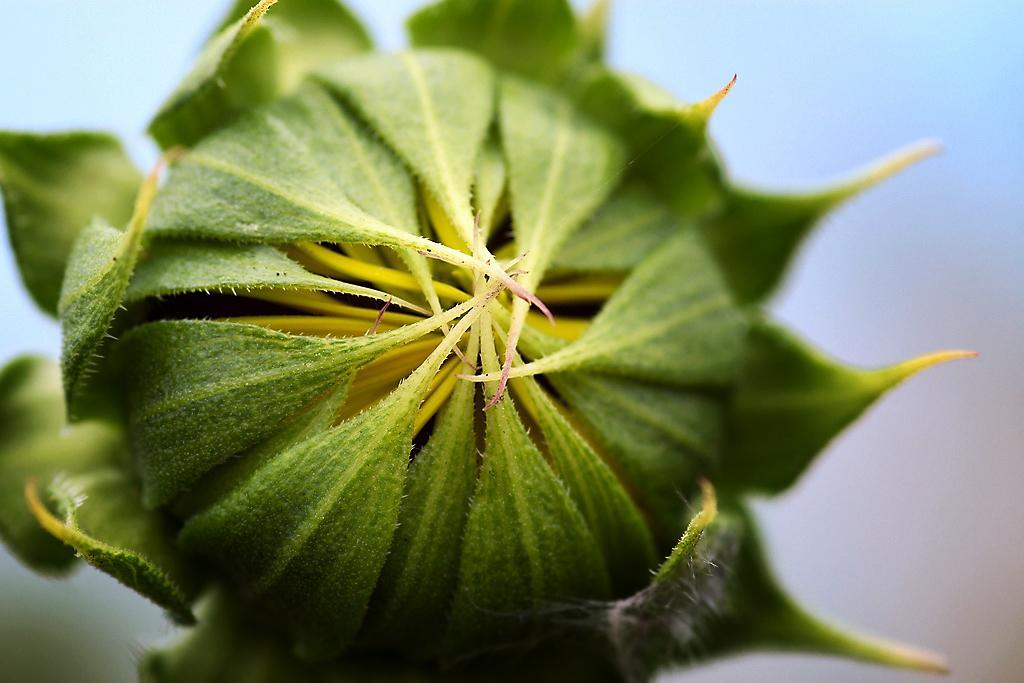In one or two sentences, can you explain what this image depicts? In the picture we can see a flower bud which is green in color. 